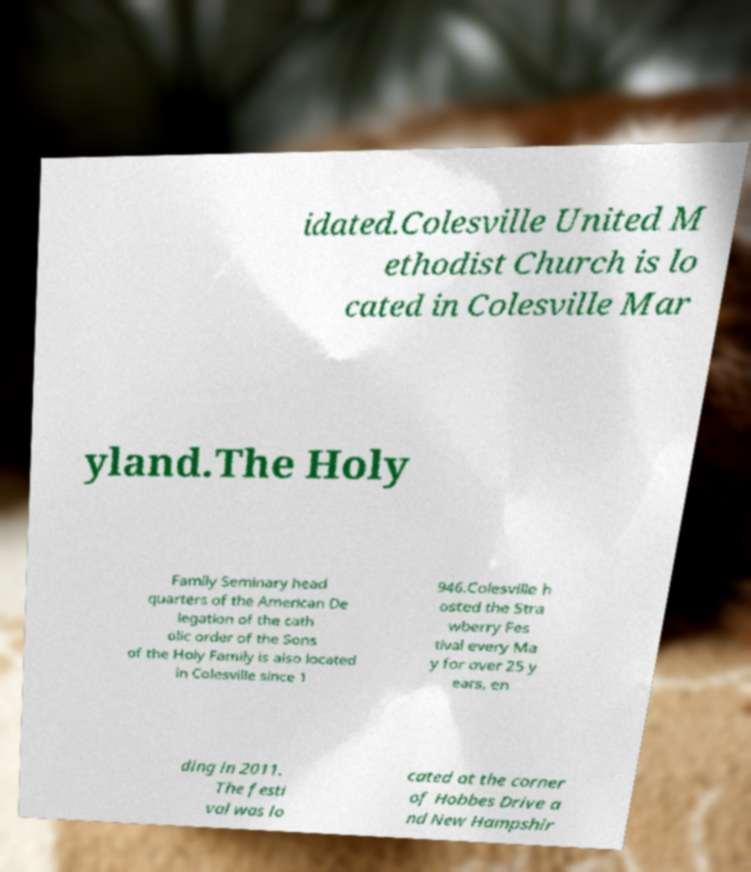Can you read and provide the text displayed in the image?This photo seems to have some interesting text. Can you extract and type it out for me? idated.Colesville United M ethodist Church is lo cated in Colesville Mar yland.The Holy Family Seminary head quarters of the American De legation of the cath olic order of the Sons of the Holy Family is also located in Colesville since 1 946.Colesville h osted the Stra wberry Fes tival every Ma y for over 25 y ears, en ding in 2011. The festi val was lo cated at the corner of Hobbes Drive a nd New Hampshir 